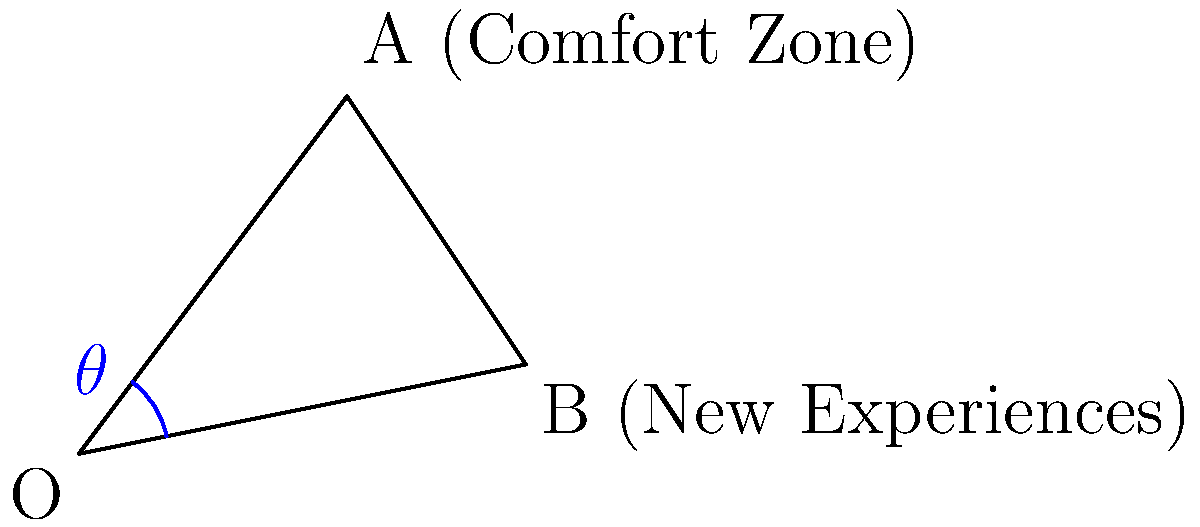In the diagram, vector $\vec{OA}$ represents your comfort zone, and vector $\vec{OB}$ represents new experiences. If $\vec{OA} = \langle 3, 4 \rangle$ and $\vec{OB} = \langle 5, 1 \rangle$, calculate the angle $\theta$ between these vectors. This angle represents the extent of stepping out of your comfort zone. Round your answer to the nearest degree. To find the angle between two vectors, we can use the dot product formula:

$$\cos \theta = \frac{\vec{OA} \cdot \vec{OB}}{|\vec{OA}||\vec{OB}|}$$

Step 1: Calculate the dot product $\vec{OA} \cdot \vec{OB}$
$$\vec{OA} \cdot \vec{OB} = (3)(5) + (4)(1) = 15 + 4 = 19$$

Step 2: Calculate the magnitudes of the vectors
$$|\vec{OA}| = \sqrt{3^2 + 4^2} = \sqrt{9 + 16} = \sqrt{25} = 5$$
$$|\vec{OB}| = \sqrt{5^2 + 1^2} = \sqrt{25 + 1} = \sqrt{26}$$

Step 3: Apply the dot product formula
$$\cos \theta = \frac{19}{5\sqrt{26}}$$

Step 4: Take the inverse cosine (arccos) of both sides
$$\theta = \arccos\left(\frac{19}{5\sqrt{26}}\right)$$

Step 5: Calculate and round to the nearest degree
$$\theta \approx 44.42^\circ \approx 44^\circ$$
Answer: $44^\circ$ 